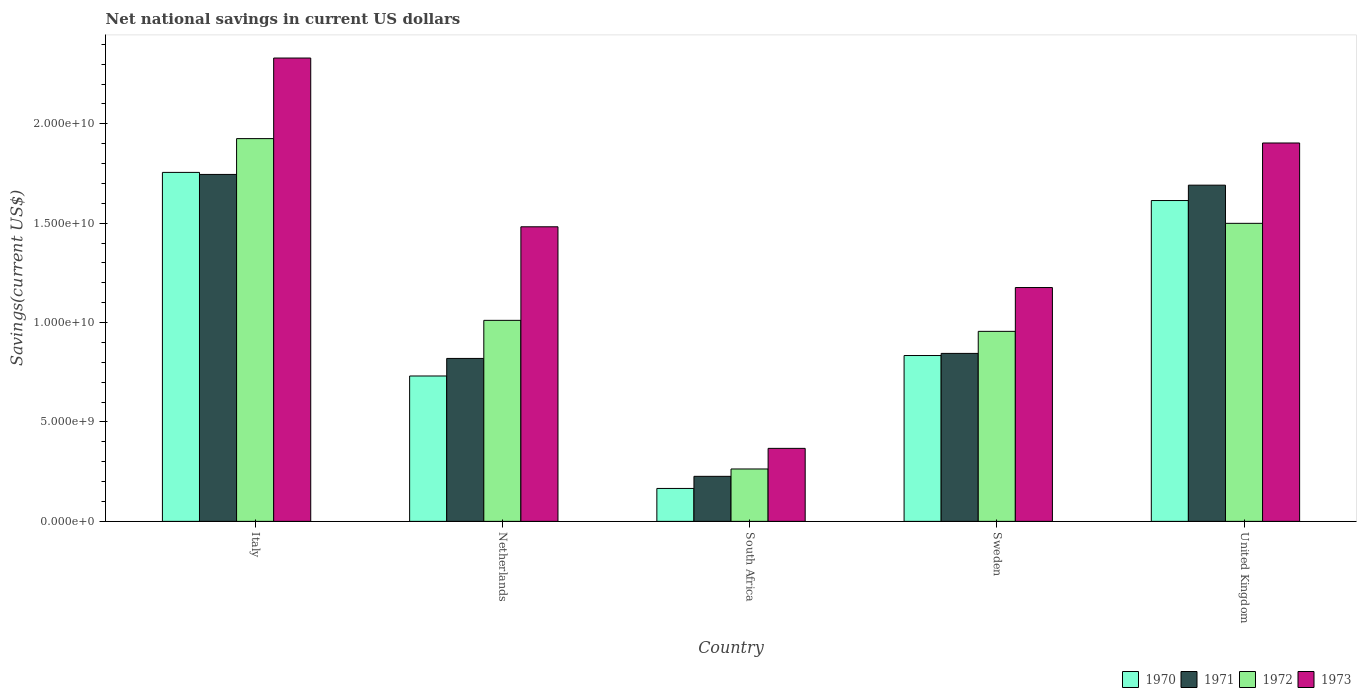How many groups of bars are there?
Your response must be concise. 5. In how many cases, is the number of bars for a given country not equal to the number of legend labels?
Offer a very short reply. 0. What is the net national savings in 1970 in Sweden?
Your response must be concise. 8.34e+09. Across all countries, what is the maximum net national savings in 1971?
Your answer should be compact. 1.75e+1. Across all countries, what is the minimum net national savings in 1973?
Give a very brief answer. 3.67e+09. In which country was the net national savings in 1971 maximum?
Give a very brief answer. Italy. In which country was the net national savings in 1970 minimum?
Your answer should be very brief. South Africa. What is the total net national savings in 1971 in the graph?
Ensure brevity in your answer.  5.33e+1. What is the difference between the net national savings in 1972 in Italy and that in United Kingdom?
Provide a short and direct response. 4.26e+09. What is the difference between the net national savings in 1971 in Netherlands and the net national savings in 1970 in United Kingdom?
Make the answer very short. -7.94e+09. What is the average net national savings in 1971 per country?
Offer a very short reply. 1.07e+1. What is the difference between the net national savings of/in 1973 and net national savings of/in 1972 in Netherlands?
Give a very brief answer. 4.71e+09. In how many countries, is the net national savings in 1972 greater than 19000000000 US$?
Your answer should be very brief. 1. What is the ratio of the net national savings in 1970 in Italy to that in Netherlands?
Your response must be concise. 2.4. Is the difference between the net national savings in 1973 in Sweden and United Kingdom greater than the difference between the net national savings in 1972 in Sweden and United Kingdom?
Offer a terse response. No. What is the difference between the highest and the second highest net national savings in 1973?
Ensure brevity in your answer.  -8.49e+09. What is the difference between the highest and the lowest net national savings in 1973?
Your answer should be compact. 1.96e+1. In how many countries, is the net national savings in 1973 greater than the average net national savings in 1973 taken over all countries?
Offer a very short reply. 3. What does the 3rd bar from the right in Italy represents?
Ensure brevity in your answer.  1971. Is it the case that in every country, the sum of the net national savings in 1970 and net national savings in 1973 is greater than the net national savings in 1972?
Make the answer very short. Yes. How many bars are there?
Your response must be concise. 20. Are all the bars in the graph horizontal?
Your answer should be compact. No. How many countries are there in the graph?
Offer a terse response. 5. Does the graph contain grids?
Your answer should be very brief. No. Where does the legend appear in the graph?
Offer a terse response. Bottom right. How many legend labels are there?
Your answer should be compact. 4. How are the legend labels stacked?
Your answer should be compact. Horizontal. What is the title of the graph?
Keep it short and to the point. Net national savings in current US dollars. What is the label or title of the Y-axis?
Offer a terse response. Savings(current US$). What is the Savings(current US$) in 1970 in Italy?
Give a very brief answer. 1.76e+1. What is the Savings(current US$) in 1971 in Italy?
Make the answer very short. 1.75e+1. What is the Savings(current US$) in 1972 in Italy?
Your answer should be compact. 1.93e+1. What is the Savings(current US$) of 1973 in Italy?
Your answer should be compact. 2.33e+1. What is the Savings(current US$) in 1970 in Netherlands?
Provide a succinct answer. 7.31e+09. What is the Savings(current US$) in 1971 in Netherlands?
Your answer should be very brief. 8.20e+09. What is the Savings(current US$) in 1972 in Netherlands?
Offer a terse response. 1.01e+1. What is the Savings(current US$) in 1973 in Netherlands?
Give a very brief answer. 1.48e+1. What is the Savings(current US$) of 1970 in South Africa?
Your response must be concise. 1.66e+09. What is the Savings(current US$) in 1971 in South Africa?
Make the answer very short. 2.27e+09. What is the Savings(current US$) of 1972 in South Africa?
Your answer should be very brief. 2.64e+09. What is the Savings(current US$) of 1973 in South Africa?
Your response must be concise. 3.67e+09. What is the Savings(current US$) of 1970 in Sweden?
Give a very brief answer. 8.34e+09. What is the Savings(current US$) of 1971 in Sweden?
Provide a succinct answer. 8.45e+09. What is the Savings(current US$) in 1972 in Sweden?
Your response must be concise. 9.56e+09. What is the Savings(current US$) in 1973 in Sweden?
Offer a terse response. 1.18e+1. What is the Savings(current US$) of 1970 in United Kingdom?
Offer a terse response. 1.61e+1. What is the Savings(current US$) of 1971 in United Kingdom?
Your response must be concise. 1.69e+1. What is the Savings(current US$) in 1972 in United Kingdom?
Keep it short and to the point. 1.50e+1. What is the Savings(current US$) in 1973 in United Kingdom?
Make the answer very short. 1.90e+1. Across all countries, what is the maximum Savings(current US$) of 1970?
Give a very brief answer. 1.76e+1. Across all countries, what is the maximum Savings(current US$) of 1971?
Provide a succinct answer. 1.75e+1. Across all countries, what is the maximum Savings(current US$) of 1972?
Offer a terse response. 1.93e+1. Across all countries, what is the maximum Savings(current US$) of 1973?
Make the answer very short. 2.33e+1. Across all countries, what is the minimum Savings(current US$) in 1970?
Provide a short and direct response. 1.66e+09. Across all countries, what is the minimum Savings(current US$) in 1971?
Keep it short and to the point. 2.27e+09. Across all countries, what is the minimum Savings(current US$) in 1972?
Provide a short and direct response. 2.64e+09. Across all countries, what is the minimum Savings(current US$) of 1973?
Provide a succinct answer. 3.67e+09. What is the total Savings(current US$) of 1970 in the graph?
Keep it short and to the point. 5.10e+1. What is the total Savings(current US$) of 1971 in the graph?
Provide a short and direct response. 5.33e+1. What is the total Savings(current US$) in 1972 in the graph?
Make the answer very short. 5.66e+1. What is the total Savings(current US$) of 1973 in the graph?
Your answer should be very brief. 7.26e+1. What is the difference between the Savings(current US$) of 1970 in Italy and that in Netherlands?
Your answer should be compact. 1.02e+1. What is the difference between the Savings(current US$) of 1971 in Italy and that in Netherlands?
Keep it short and to the point. 9.26e+09. What is the difference between the Savings(current US$) of 1972 in Italy and that in Netherlands?
Your answer should be very brief. 9.14e+09. What is the difference between the Savings(current US$) of 1973 in Italy and that in Netherlands?
Ensure brevity in your answer.  8.49e+09. What is the difference between the Savings(current US$) in 1970 in Italy and that in South Africa?
Keep it short and to the point. 1.59e+1. What is the difference between the Savings(current US$) of 1971 in Italy and that in South Africa?
Provide a short and direct response. 1.52e+1. What is the difference between the Savings(current US$) of 1972 in Italy and that in South Africa?
Provide a succinct answer. 1.66e+1. What is the difference between the Savings(current US$) in 1973 in Italy and that in South Africa?
Your answer should be compact. 1.96e+1. What is the difference between the Savings(current US$) in 1970 in Italy and that in Sweden?
Provide a short and direct response. 9.21e+09. What is the difference between the Savings(current US$) in 1971 in Italy and that in Sweden?
Keep it short and to the point. 9.00e+09. What is the difference between the Savings(current US$) in 1972 in Italy and that in Sweden?
Your answer should be very brief. 9.70e+09. What is the difference between the Savings(current US$) in 1973 in Italy and that in Sweden?
Keep it short and to the point. 1.15e+1. What is the difference between the Savings(current US$) of 1970 in Italy and that in United Kingdom?
Offer a terse response. 1.42e+09. What is the difference between the Savings(current US$) in 1971 in Italy and that in United Kingdom?
Ensure brevity in your answer.  5.40e+08. What is the difference between the Savings(current US$) of 1972 in Italy and that in United Kingdom?
Make the answer very short. 4.26e+09. What is the difference between the Savings(current US$) of 1973 in Italy and that in United Kingdom?
Provide a succinct answer. 4.27e+09. What is the difference between the Savings(current US$) in 1970 in Netherlands and that in South Africa?
Keep it short and to the point. 5.66e+09. What is the difference between the Savings(current US$) in 1971 in Netherlands and that in South Africa?
Your answer should be very brief. 5.93e+09. What is the difference between the Savings(current US$) of 1972 in Netherlands and that in South Africa?
Provide a succinct answer. 7.48e+09. What is the difference between the Savings(current US$) of 1973 in Netherlands and that in South Africa?
Provide a succinct answer. 1.11e+1. What is the difference between the Savings(current US$) of 1970 in Netherlands and that in Sweden?
Your answer should be very brief. -1.03e+09. What is the difference between the Savings(current US$) in 1971 in Netherlands and that in Sweden?
Give a very brief answer. -2.53e+08. What is the difference between the Savings(current US$) of 1972 in Netherlands and that in Sweden?
Your response must be concise. 5.54e+08. What is the difference between the Savings(current US$) in 1973 in Netherlands and that in Sweden?
Your answer should be very brief. 3.06e+09. What is the difference between the Savings(current US$) in 1970 in Netherlands and that in United Kingdom?
Your answer should be compact. -8.83e+09. What is the difference between the Savings(current US$) of 1971 in Netherlands and that in United Kingdom?
Ensure brevity in your answer.  -8.72e+09. What is the difference between the Savings(current US$) of 1972 in Netherlands and that in United Kingdom?
Ensure brevity in your answer.  -4.88e+09. What is the difference between the Savings(current US$) in 1973 in Netherlands and that in United Kingdom?
Provide a succinct answer. -4.22e+09. What is the difference between the Savings(current US$) of 1970 in South Africa and that in Sweden?
Keep it short and to the point. -6.69e+09. What is the difference between the Savings(current US$) in 1971 in South Africa and that in Sweden?
Provide a short and direct response. -6.18e+09. What is the difference between the Savings(current US$) in 1972 in South Africa and that in Sweden?
Offer a very short reply. -6.92e+09. What is the difference between the Savings(current US$) of 1973 in South Africa and that in Sweden?
Offer a terse response. -8.09e+09. What is the difference between the Savings(current US$) of 1970 in South Africa and that in United Kingdom?
Your answer should be compact. -1.45e+1. What is the difference between the Savings(current US$) of 1971 in South Africa and that in United Kingdom?
Your answer should be compact. -1.46e+1. What is the difference between the Savings(current US$) in 1972 in South Africa and that in United Kingdom?
Keep it short and to the point. -1.24e+1. What is the difference between the Savings(current US$) of 1973 in South Africa and that in United Kingdom?
Offer a terse response. -1.54e+1. What is the difference between the Savings(current US$) of 1970 in Sweden and that in United Kingdom?
Keep it short and to the point. -7.80e+09. What is the difference between the Savings(current US$) in 1971 in Sweden and that in United Kingdom?
Keep it short and to the point. -8.46e+09. What is the difference between the Savings(current US$) of 1972 in Sweden and that in United Kingdom?
Your answer should be very brief. -5.43e+09. What is the difference between the Savings(current US$) in 1973 in Sweden and that in United Kingdom?
Keep it short and to the point. -7.27e+09. What is the difference between the Savings(current US$) in 1970 in Italy and the Savings(current US$) in 1971 in Netherlands?
Provide a succinct answer. 9.36e+09. What is the difference between the Savings(current US$) of 1970 in Italy and the Savings(current US$) of 1972 in Netherlands?
Provide a succinct answer. 7.44e+09. What is the difference between the Savings(current US$) of 1970 in Italy and the Savings(current US$) of 1973 in Netherlands?
Offer a very short reply. 2.74e+09. What is the difference between the Savings(current US$) in 1971 in Italy and the Savings(current US$) in 1972 in Netherlands?
Make the answer very short. 7.34e+09. What is the difference between the Savings(current US$) of 1971 in Italy and the Savings(current US$) of 1973 in Netherlands?
Keep it short and to the point. 2.63e+09. What is the difference between the Savings(current US$) of 1972 in Italy and the Savings(current US$) of 1973 in Netherlands?
Provide a succinct answer. 4.44e+09. What is the difference between the Savings(current US$) of 1970 in Italy and the Savings(current US$) of 1971 in South Africa?
Offer a terse response. 1.53e+1. What is the difference between the Savings(current US$) of 1970 in Italy and the Savings(current US$) of 1972 in South Africa?
Give a very brief answer. 1.49e+1. What is the difference between the Savings(current US$) of 1970 in Italy and the Savings(current US$) of 1973 in South Africa?
Keep it short and to the point. 1.39e+1. What is the difference between the Savings(current US$) of 1971 in Italy and the Savings(current US$) of 1972 in South Africa?
Offer a very short reply. 1.48e+1. What is the difference between the Savings(current US$) of 1971 in Italy and the Savings(current US$) of 1973 in South Africa?
Offer a terse response. 1.38e+1. What is the difference between the Savings(current US$) of 1972 in Italy and the Savings(current US$) of 1973 in South Africa?
Provide a succinct answer. 1.56e+1. What is the difference between the Savings(current US$) of 1970 in Italy and the Savings(current US$) of 1971 in Sweden?
Make the answer very short. 9.11e+09. What is the difference between the Savings(current US$) in 1970 in Italy and the Savings(current US$) in 1972 in Sweden?
Offer a very short reply. 8.00e+09. What is the difference between the Savings(current US$) of 1970 in Italy and the Savings(current US$) of 1973 in Sweden?
Offer a very short reply. 5.79e+09. What is the difference between the Savings(current US$) in 1971 in Italy and the Savings(current US$) in 1972 in Sweden?
Make the answer very short. 7.89e+09. What is the difference between the Savings(current US$) in 1971 in Italy and the Savings(current US$) in 1973 in Sweden?
Offer a very short reply. 5.69e+09. What is the difference between the Savings(current US$) of 1972 in Italy and the Savings(current US$) of 1973 in Sweden?
Your answer should be compact. 7.49e+09. What is the difference between the Savings(current US$) in 1970 in Italy and the Savings(current US$) in 1971 in United Kingdom?
Keep it short and to the point. 6.43e+08. What is the difference between the Savings(current US$) of 1970 in Italy and the Savings(current US$) of 1972 in United Kingdom?
Give a very brief answer. 2.56e+09. What is the difference between the Savings(current US$) of 1970 in Italy and the Savings(current US$) of 1973 in United Kingdom?
Give a very brief answer. -1.48e+09. What is the difference between the Savings(current US$) in 1971 in Italy and the Savings(current US$) in 1972 in United Kingdom?
Offer a very short reply. 2.46e+09. What is the difference between the Savings(current US$) of 1971 in Italy and the Savings(current US$) of 1973 in United Kingdom?
Provide a short and direct response. -1.58e+09. What is the difference between the Savings(current US$) of 1972 in Italy and the Savings(current US$) of 1973 in United Kingdom?
Your answer should be very brief. 2.20e+08. What is the difference between the Savings(current US$) of 1970 in Netherlands and the Savings(current US$) of 1971 in South Africa?
Give a very brief answer. 5.05e+09. What is the difference between the Savings(current US$) of 1970 in Netherlands and the Savings(current US$) of 1972 in South Africa?
Ensure brevity in your answer.  4.68e+09. What is the difference between the Savings(current US$) in 1970 in Netherlands and the Savings(current US$) in 1973 in South Africa?
Your answer should be very brief. 3.64e+09. What is the difference between the Savings(current US$) of 1971 in Netherlands and the Savings(current US$) of 1972 in South Africa?
Give a very brief answer. 5.56e+09. What is the difference between the Savings(current US$) in 1971 in Netherlands and the Savings(current US$) in 1973 in South Africa?
Provide a succinct answer. 4.52e+09. What is the difference between the Savings(current US$) in 1972 in Netherlands and the Savings(current US$) in 1973 in South Africa?
Provide a succinct answer. 6.44e+09. What is the difference between the Savings(current US$) of 1970 in Netherlands and the Savings(current US$) of 1971 in Sweden?
Provide a succinct answer. -1.14e+09. What is the difference between the Savings(current US$) of 1970 in Netherlands and the Savings(current US$) of 1972 in Sweden?
Provide a succinct answer. -2.25e+09. What is the difference between the Savings(current US$) of 1970 in Netherlands and the Savings(current US$) of 1973 in Sweden?
Offer a terse response. -4.45e+09. What is the difference between the Savings(current US$) of 1971 in Netherlands and the Savings(current US$) of 1972 in Sweden?
Your answer should be very brief. -1.36e+09. What is the difference between the Savings(current US$) of 1971 in Netherlands and the Savings(current US$) of 1973 in Sweden?
Offer a terse response. -3.57e+09. What is the difference between the Savings(current US$) in 1972 in Netherlands and the Savings(current US$) in 1973 in Sweden?
Provide a succinct answer. -1.65e+09. What is the difference between the Savings(current US$) in 1970 in Netherlands and the Savings(current US$) in 1971 in United Kingdom?
Provide a short and direct response. -9.60e+09. What is the difference between the Savings(current US$) in 1970 in Netherlands and the Savings(current US$) in 1972 in United Kingdom?
Ensure brevity in your answer.  -7.68e+09. What is the difference between the Savings(current US$) in 1970 in Netherlands and the Savings(current US$) in 1973 in United Kingdom?
Provide a short and direct response. -1.17e+1. What is the difference between the Savings(current US$) of 1971 in Netherlands and the Savings(current US$) of 1972 in United Kingdom?
Make the answer very short. -6.80e+09. What is the difference between the Savings(current US$) in 1971 in Netherlands and the Savings(current US$) in 1973 in United Kingdom?
Your answer should be compact. -1.08e+1. What is the difference between the Savings(current US$) of 1972 in Netherlands and the Savings(current US$) of 1973 in United Kingdom?
Provide a short and direct response. -8.92e+09. What is the difference between the Savings(current US$) in 1970 in South Africa and the Savings(current US$) in 1971 in Sweden?
Keep it short and to the point. -6.79e+09. What is the difference between the Savings(current US$) of 1970 in South Africa and the Savings(current US$) of 1972 in Sweden?
Offer a terse response. -7.90e+09. What is the difference between the Savings(current US$) in 1970 in South Africa and the Savings(current US$) in 1973 in Sweden?
Provide a short and direct response. -1.01e+1. What is the difference between the Savings(current US$) of 1971 in South Africa and the Savings(current US$) of 1972 in Sweden?
Provide a short and direct response. -7.29e+09. What is the difference between the Savings(current US$) of 1971 in South Africa and the Savings(current US$) of 1973 in Sweden?
Make the answer very short. -9.50e+09. What is the difference between the Savings(current US$) in 1972 in South Africa and the Savings(current US$) in 1973 in Sweden?
Offer a very short reply. -9.13e+09. What is the difference between the Savings(current US$) of 1970 in South Africa and the Savings(current US$) of 1971 in United Kingdom?
Your answer should be very brief. -1.53e+1. What is the difference between the Savings(current US$) in 1970 in South Africa and the Savings(current US$) in 1972 in United Kingdom?
Offer a very short reply. -1.33e+1. What is the difference between the Savings(current US$) in 1970 in South Africa and the Savings(current US$) in 1973 in United Kingdom?
Give a very brief answer. -1.74e+1. What is the difference between the Savings(current US$) of 1971 in South Africa and the Savings(current US$) of 1972 in United Kingdom?
Make the answer very short. -1.27e+1. What is the difference between the Savings(current US$) of 1971 in South Africa and the Savings(current US$) of 1973 in United Kingdom?
Offer a very short reply. -1.68e+1. What is the difference between the Savings(current US$) in 1972 in South Africa and the Savings(current US$) in 1973 in United Kingdom?
Ensure brevity in your answer.  -1.64e+1. What is the difference between the Savings(current US$) of 1970 in Sweden and the Savings(current US$) of 1971 in United Kingdom?
Offer a terse response. -8.57e+09. What is the difference between the Savings(current US$) in 1970 in Sweden and the Savings(current US$) in 1972 in United Kingdom?
Provide a succinct answer. -6.65e+09. What is the difference between the Savings(current US$) in 1970 in Sweden and the Savings(current US$) in 1973 in United Kingdom?
Make the answer very short. -1.07e+1. What is the difference between the Savings(current US$) in 1971 in Sweden and the Savings(current US$) in 1972 in United Kingdom?
Give a very brief answer. -6.54e+09. What is the difference between the Savings(current US$) of 1971 in Sweden and the Savings(current US$) of 1973 in United Kingdom?
Your answer should be compact. -1.06e+1. What is the difference between the Savings(current US$) of 1972 in Sweden and the Savings(current US$) of 1973 in United Kingdom?
Your answer should be very brief. -9.48e+09. What is the average Savings(current US$) of 1970 per country?
Keep it short and to the point. 1.02e+1. What is the average Savings(current US$) of 1971 per country?
Provide a succinct answer. 1.07e+1. What is the average Savings(current US$) in 1972 per country?
Ensure brevity in your answer.  1.13e+1. What is the average Savings(current US$) of 1973 per country?
Make the answer very short. 1.45e+1. What is the difference between the Savings(current US$) of 1970 and Savings(current US$) of 1971 in Italy?
Your response must be concise. 1.03e+08. What is the difference between the Savings(current US$) in 1970 and Savings(current US$) in 1972 in Italy?
Offer a very short reply. -1.70e+09. What is the difference between the Savings(current US$) in 1970 and Savings(current US$) in 1973 in Italy?
Offer a very short reply. -5.75e+09. What is the difference between the Savings(current US$) in 1971 and Savings(current US$) in 1972 in Italy?
Ensure brevity in your answer.  -1.80e+09. What is the difference between the Savings(current US$) of 1971 and Savings(current US$) of 1973 in Italy?
Ensure brevity in your answer.  -5.86e+09. What is the difference between the Savings(current US$) of 1972 and Savings(current US$) of 1973 in Italy?
Make the answer very short. -4.05e+09. What is the difference between the Savings(current US$) of 1970 and Savings(current US$) of 1971 in Netherlands?
Offer a very short reply. -8.83e+08. What is the difference between the Savings(current US$) of 1970 and Savings(current US$) of 1972 in Netherlands?
Make the answer very short. -2.80e+09. What is the difference between the Savings(current US$) of 1970 and Savings(current US$) of 1973 in Netherlands?
Offer a terse response. -7.51e+09. What is the difference between the Savings(current US$) in 1971 and Savings(current US$) in 1972 in Netherlands?
Give a very brief answer. -1.92e+09. What is the difference between the Savings(current US$) of 1971 and Savings(current US$) of 1973 in Netherlands?
Keep it short and to the point. -6.62e+09. What is the difference between the Savings(current US$) in 1972 and Savings(current US$) in 1973 in Netherlands?
Your answer should be very brief. -4.71e+09. What is the difference between the Savings(current US$) of 1970 and Savings(current US$) of 1971 in South Africa?
Ensure brevity in your answer.  -6.09e+08. What is the difference between the Savings(current US$) in 1970 and Savings(current US$) in 1972 in South Africa?
Provide a short and direct response. -9.79e+08. What is the difference between the Savings(current US$) in 1970 and Savings(current US$) in 1973 in South Africa?
Offer a terse response. -2.02e+09. What is the difference between the Savings(current US$) of 1971 and Savings(current US$) of 1972 in South Africa?
Make the answer very short. -3.70e+08. What is the difference between the Savings(current US$) in 1971 and Savings(current US$) in 1973 in South Africa?
Keep it short and to the point. -1.41e+09. What is the difference between the Savings(current US$) in 1972 and Savings(current US$) in 1973 in South Africa?
Your answer should be very brief. -1.04e+09. What is the difference between the Savings(current US$) of 1970 and Savings(current US$) of 1971 in Sweden?
Your answer should be compact. -1.07e+08. What is the difference between the Savings(current US$) of 1970 and Savings(current US$) of 1972 in Sweden?
Your answer should be very brief. -1.22e+09. What is the difference between the Savings(current US$) in 1970 and Savings(current US$) in 1973 in Sweden?
Give a very brief answer. -3.42e+09. What is the difference between the Savings(current US$) of 1971 and Savings(current US$) of 1972 in Sweden?
Make the answer very short. -1.11e+09. What is the difference between the Savings(current US$) in 1971 and Savings(current US$) in 1973 in Sweden?
Ensure brevity in your answer.  -3.31e+09. What is the difference between the Savings(current US$) in 1972 and Savings(current US$) in 1973 in Sweden?
Offer a very short reply. -2.20e+09. What is the difference between the Savings(current US$) of 1970 and Savings(current US$) of 1971 in United Kingdom?
Ensure brevity in your answer.  -7.74e+08. What is the difference between the Savings(current US$) of 1970 and Savings(current US$) of 1972 in United Kingdom?
Provide a succinct answer. 1.15e+09. What is the difference between the Savings(current US$) of 1970 and Savings(current US$) of 1973 in United Kingdom?
Ensure brevity in your answer.  -2.90e+09. What is the difference between the Savings(current US$) in 1971 and Savings(current US$) in 1972 in United Kingdom?
Offer a terse response. 1.92e+09. What is the difference between the Savings(current US$) of 1971 and Savings(current US$) of 1973 in United Kingdom?
Keep it short and to the point. -2.12e+09. What is the difference between the Savings(current US$) in 1972 and Savings(current US$) in 1973 in United Kingdom?
Give a very brief answer. -4.04e+09. What is the ratio of the Savings(current US$) in 1970 in Italy to that in Netherlands?
Offer a very short reply. 2.4. What is the ratio of the Savings(current US$) of 1971 in Italy to that in Netherlands?
Your answer should be compact. 2.13. What is the ratio of the Savings(current US$) of 1972 in Italy to that in Netherlands?
Offer a terse response. 1.9. What is the ratio of the Savings(current US$) of 1973 in Italy to that in Netherlands?
Provide a short and direct response. 1.57. What is the ratio of the Savings(current US$) in 1970 in Italy to that in South Africa?
Keep it short and to the point. 10.6. What is the ratio of the Savings(current US$) in 1971 in Italy to that in South Africa?
Your answer should be very brief. 7.7. What is the ratio of the Savings(current US$) of 1972 in Italy to that in South Africa?
Keep it short and to the point. 7.31. What is the ratio of the Savings(current US$) of 1973 in Italy to that in South Africa?
Your answer should be very brief. 6.35. What is the ratio of the Savings(current US$) in 1970 in Italy to that in Sweden?
Ensure brevity in your answer.  2.1. What is the ratio of the Savings(current US$) in 1971 in Italy to that in Sweden?
Make the answer very short. 2.07. What is the ratio of the Savings(current US$) of 1972 in Italy to that in Sweden?
Give a very brief answer. 2.01. What is the ratio of the Savings(current US$) of 1973 in Italy to that in Sweden?
Provide a succinct answer. 1.98. What is the ratio of the Savings(current US$) in 1970 in Italy to that in United Kingdom?
Offer a terse response. 1.09. What is the ratio of the Savings(current US$) in 1971 in Italy to that in United Kingdom?
Keep it short and to the point. 1.03. What is the ratio of the Savings(current US$) of 1972 in Italy to that in United Kingdom?
Your response must be concise. 1.28. What is the ratio of the Savings(current US$) of 1973 in Italy to that in United Kingdom?
Give a very brief answer. 1.22. What is the ratio of the Savings(current US$) in 1970 in Netherlands to that in South Africa?
Offer a very short reply. 4.42. What is the ratio of the Savings(current US$) in 1971 in Netherlands to that in South Africa?
Ensure brevity in your answer.  3.62. What is the ratio of the Savings(current US$) in 1972 in Netherlands to that in South Africa?
Your answer should be compact. 3.84. What is the ratio of the Savings(current US$) in 1973 in Netherlands to that in South Africa?
Your response must be concise. 4.04. What is the ratio of the Savings(current US$) of 1970 in Netherlands to that in Sweden?
Make the answer very short. 0.88. What is the ratio of the Savings(current US$) of 1971 in Netherlands to that in Sweden?
Offer a terse response. 0.97. What is the ratio of the Savings(current US$) in 1972 in Netherlands to that in Sweden?
Your answer should be compact. 1.06. What is the ratio of the Savings(current US$) of 1973 in Netherlands to that in Sweden?
Ensure brevity in your answer.  1.26. What is the ratio of the Savings(current US$) in 1970 in Netherlands to that in United Kingdom?
Ensure brevity in your answer.  0.45. What is the ratio of the Savings(current US$) of 1971 in Netherlands to that in United Kingdom?
Ensure brevity in your answer.  0.48. What is the ratio of the Savings(current US$) in 1972 in Netherlands to that in United Kingdom?
Your answer should be very brief. 0.67. What is the ratio of the Savings(current US$) in 1973 in Netherlands to that in United Kingdom?
Your answer should be compact. 0.78. What is the ratio of the Savings(current US$) of 1970 in South Africa to that in Sweden?
Your answer should be compact. 0.2. What is the ratio of the Savings(current US$) in 1971 in South Africa to that in Sweden?
Your answer should be compact. 0.27. What is the ratio of the Savings(current US$) in 1972 in South Africa to that in Sweden?
Your answer should be compact. 0.28. What is the ratio of the Savings(current US$) of 1973 in South Africa to that in Sweden?
Provide a succinct answer. 0.31. What is the ratio of the Savings(current US$) in 1970 in South Africa to that in United Kingdom?
Offer a terse response. 0.1. What is the ratio of the Savings(current US$) in 1971 in South Africa to that in United Kingdom?
Your answer should be very brief. 0.13. What is the ratio of the Savings(current US$) in 1972 in South Africa to that in United Kingdom?
Make the answer very short. 0.18. What is the ratio of the Savings(current US$) of 1973 in South Africa to that in United Kingdom?
Your answer should be compact. 0.19. What is the ratio of the Savings(current US$) of 1970 in Sweden to that in United Kingdom?
Provide a short and direct response. 0.52. What is the ratio of the Savings(current US$) of 1971 in Sweden to that in United Kingdom?
Your answer should be compact. 0.5. What is the ratio of the Savings(current US$) in 1972 in Sweden to that in United Kingdom?
Provide a succinct answer. 0.64. What is the ratio of the Savings(current US$) in 1973 in Sweden to that in United Kingdom?
Give a very brief answer. 0.62. What is the difference between the highest and the second highest Savings(current US$) of 1970?
Offer a very short reply. 1.42e+09. What is the difference between the highest and the second highest Savings(current US$) in 1971?
Your response must be concise. 5.40e+08. What is the difference between the highest and the second highest Savings(current US$) of 1972?
Make the answer very short. 4.26e+09. What is the difference between the highest and the second highest Savings(current US$) of 1973?
Your answer should be compact. 4.27e+09. What is the difference between the highest and the lowest Savings(current US$) in 1970?
Give a very brief answer. 1.59e+1. What is the difference between the highest and the lowest Savings(current US$) in 1971?
Ensure brevity in your answer.  1.52e+1. What is the difference between the highest and the lowest Savings(current US$) in 1972?
Provide a succinct answer. 1.66e+1. What is the difference between the highest and the lowest Savings(current US$) of 1973?
Your response must be concise. 1.96e+1. 